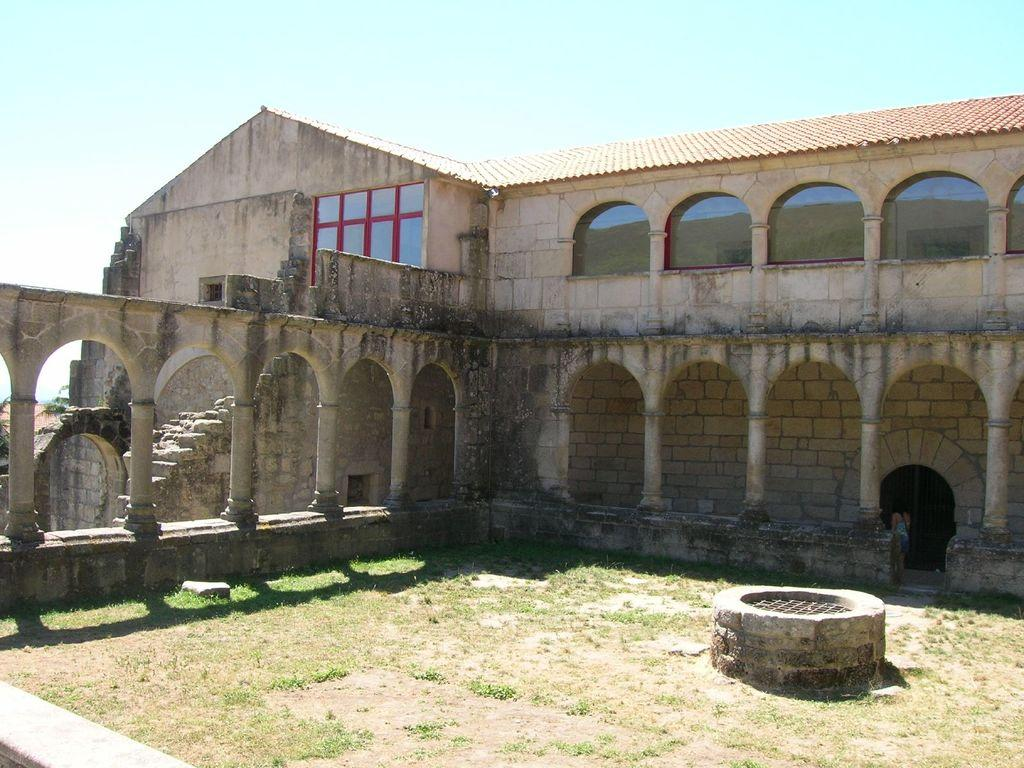What structure is visible in the image? There is a building in the image. Where is the person located in the image? The person is on the right side of the image. What type of vegetation is at the bottom of the image? There is grass at the bottom of the image. What can be seen in the background of the image? The sky and a well are visible in the background of the image. Where is the cloth hanging in the image? There is no cloth present in the image. What type of sack is visible on the person's back in the image? There is no sack visible on the person's back in the image. 